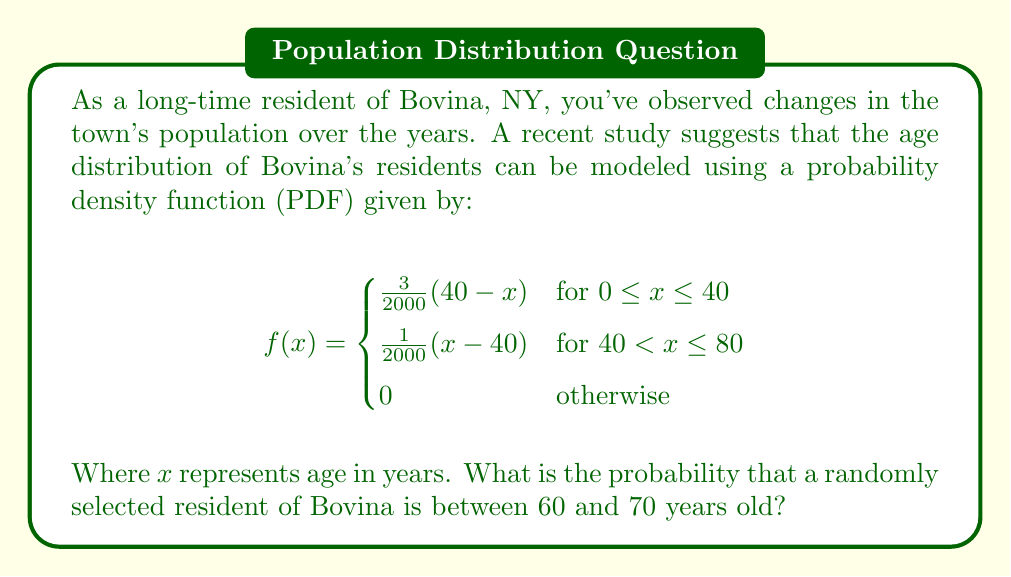Help me with this question. To solve this problem, we need to integrate the probability density function over the interval [60, 70]. This will give us the area under the curve between these two age points, which represents the probability of selecting a resident within this age range.

Given that the interval [60, 70] falls within the second piece of our piecewise function, we'll use the equation $f(x) = \frac{1}{2000}(x-40)$ for our integration.

The probability is given by the definite integral:

$$P(60 \leq X \leq 70) = \int_{60}^{70} \frac{1}{2000}(x-40) dx$$

Let's solve this integral step by step:

1) First, let's integrate:
   $$\int \frac{1}{2000}(x-40) dx = \frac{1}{2000}(\frac{x^2}{2} - 40x) + C$$

2) Now, let's apply the limits:
   $$\left[\frac{1}{2000}(\frac{x^2}{2} - 40x)\right]_{60}^{70}$$

3) Evaluate at x = 70:
   $$\frac{1}{2000}(\frac{70^2}{2} - 40(70)) = \frac{1}{2000}(2450 - 2800) = -\frac{350}{2000}$$

4) Evaluate at x = 60:
   $$\frac{1}{2000}(\frac{60^2}{2} - 40(60)) = \frac{1}{2000}(1800 - 2400) = -\frac{600}{2000}$$

5) Subtract the lower limit from the upper limit:
   $$-\frac{350}{2000} - (-\frac{600}{2000}) = \frac{250}{2000} = \frac{1}{8} = 0.125$$

Therefore, the probability that a randomly selected resident of Bovina is between 60 and 70 years old is 0.125 or 12.5%.
Answer: 0.125 or 12.5% 